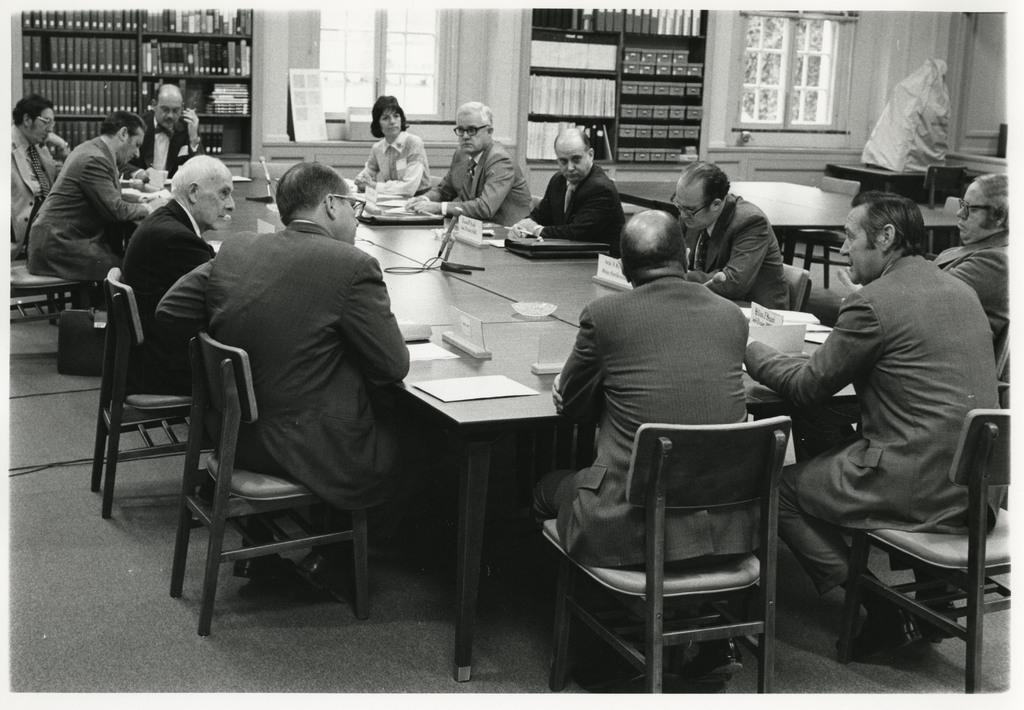What are the people in the image doing? The people in the image are sitting on a table. What can be seen in the background of the image? There are many books in the background. How are the books arranged in the image? The books are kept inside a wooden shelf. What type of feeling can be seen on the edge of the table in the image? There is no feeling or emotion visible on the edge of the table in the image. 